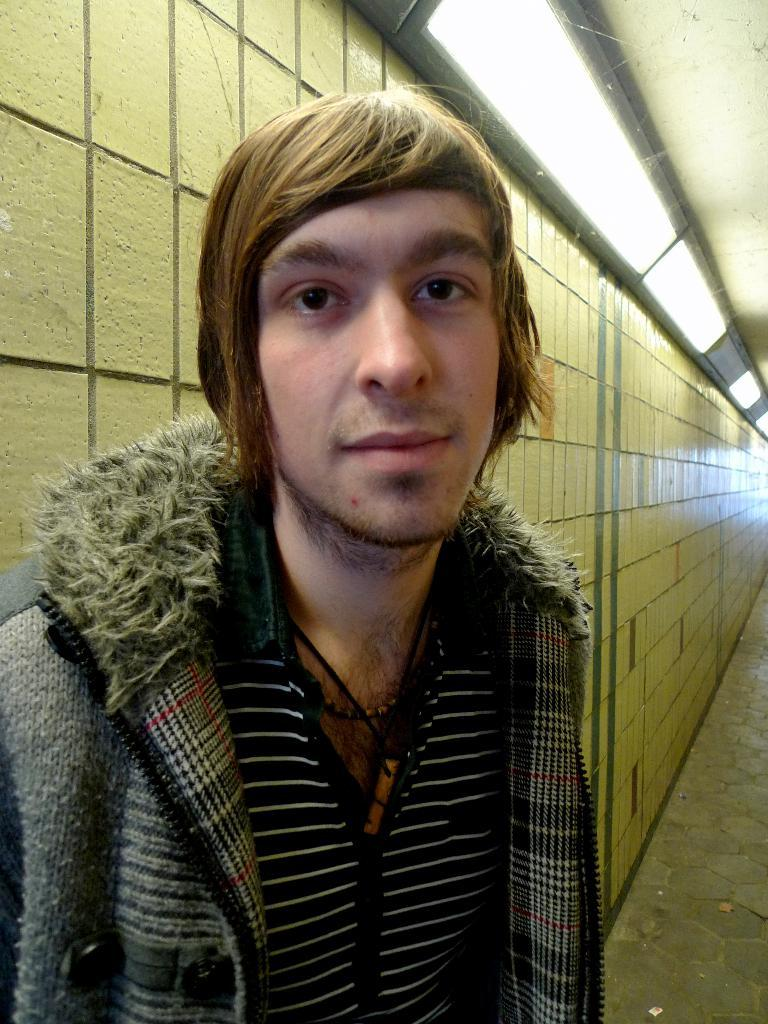Who is present in the image? There is a man in the image. Where is the man located in relation to the image? The man is standing in the foreground. What can be seen in the background of the image? There is a wall visible in the background of the image. What type of activity is the man participating in, as seen in the image? The image does not show the man participating in any specific activity. 